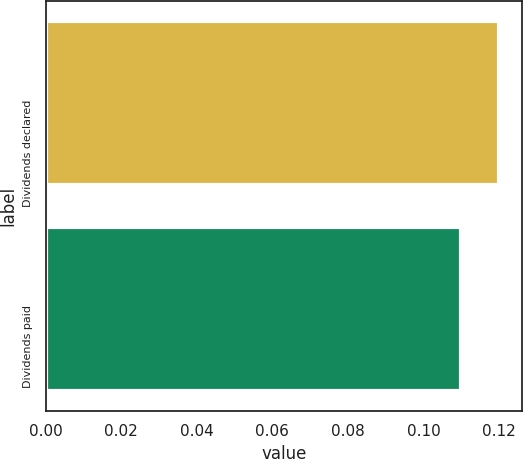Convert chart. <chart><loc_0><loc_0><loc_500><loc_500><bar_chart><fcel>Dividends declared<fcel>Dividends paid<nl><fcel>0.12<fcel>0.11<nl></chart> 